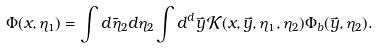<formula> <loc_0><loc_0><loc_500><loc_500>\Phi ( x , \eta _ { 1 } ) = \int d \bar { \eta } _ { 2 } d \eta _ { 2 } \int d ^ { d } \vec { y } \, { \mathcal { K } } ( x , \vec { y } , \eta _ { 1 } , \eta _ { 2 } ) \Phi _ { b } ( \vec { y } , \eta _ { 2 } ) .</formula> 